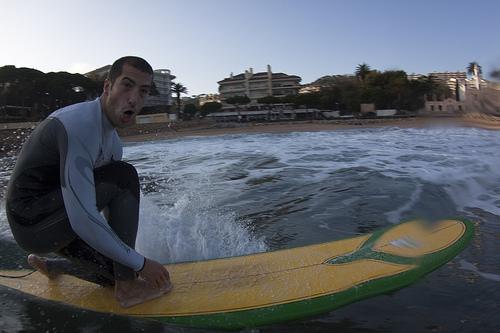How many surfers there there?
Give a very brief answer. 1. 